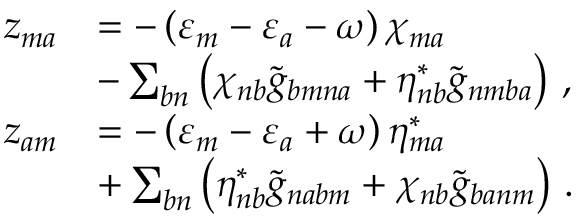<formula> <loc_0><loc_0><loc_500><loc_500>\begin{array} { r l } { z _ { m a } } & { = - \left ( \varepsilon _ { m } - \varepsilon _ { a } - \omega \right ) \chi _ { m a } } \\ & { - \sum _ { b n } \left ( \chi _ { n b } \tilde { g } _ { b m n a } + \eta _ { n b } ^ { * } \tilde { g } _ { n m b a } \right ) \, , } \\ { z _ { a m } } & { = - \left ( \varepsilon _ { m } - \varepsilon _ { a } + \omega \right ) \eta _ { m a } ^ { * } } \\ & { + \sum _ { b n } \left ( \eta _ { n b } ^ { * } \tilde { g } _ { n a b m } + \chi _ { n b } \tilde { g } _ { b a n m } \right ) \, . } \end{array}</formula> 